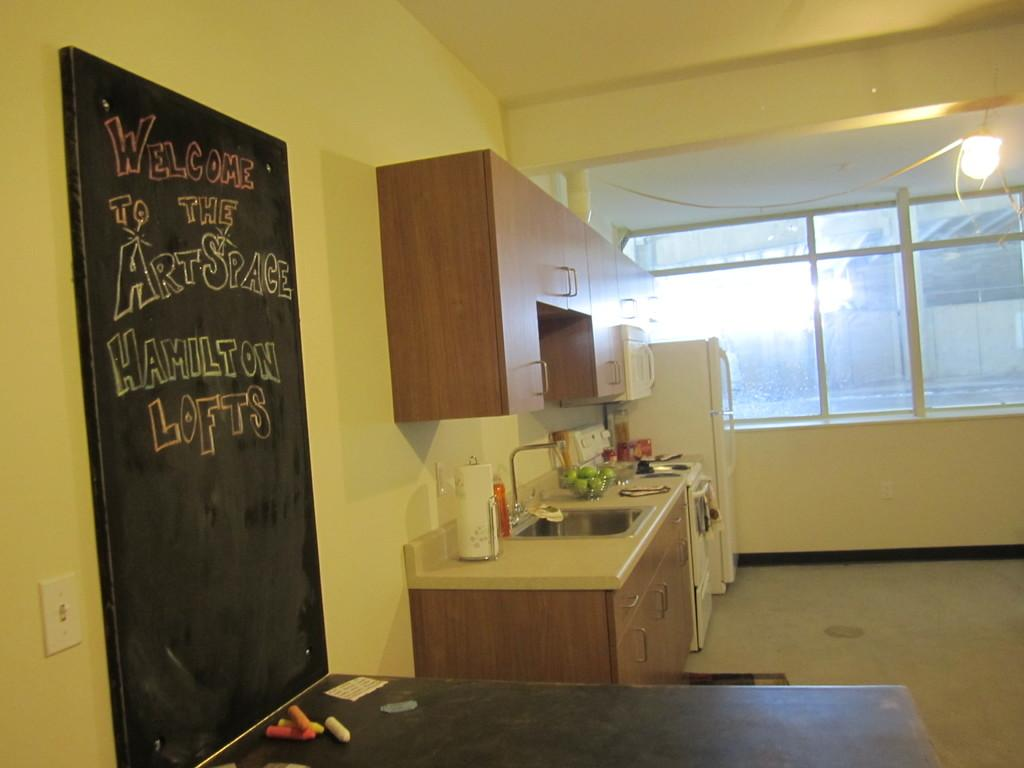<image>
Give a short and clear explanation of the subsequent image. a shared kitchen with black board that reads Welcome to the Art Space 